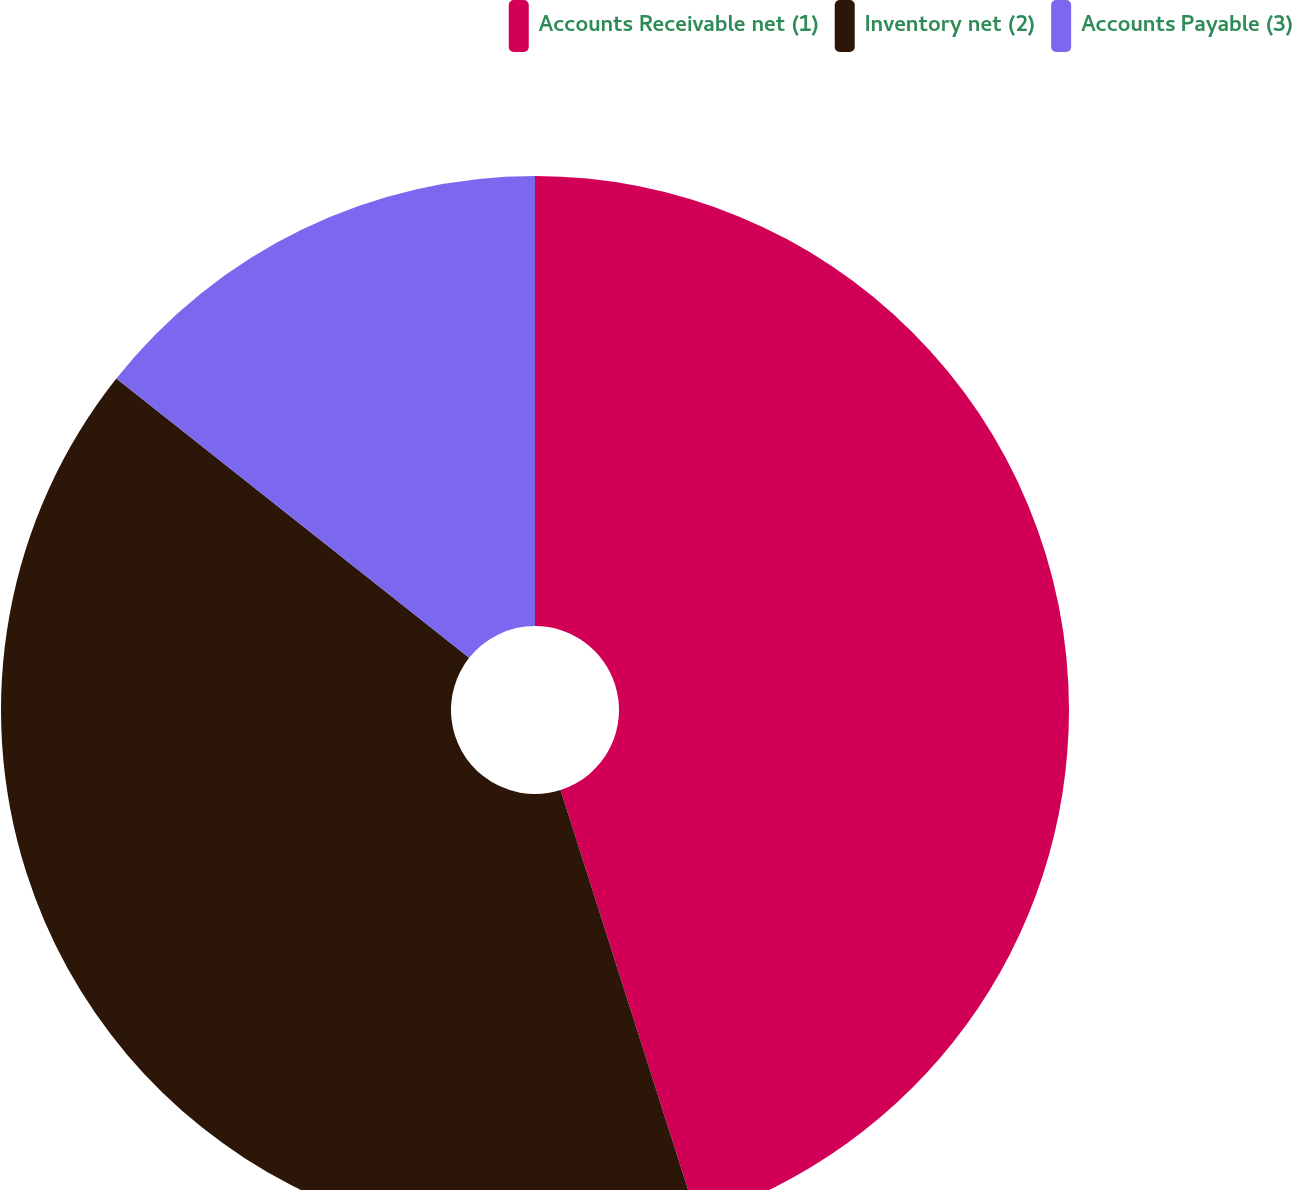<chart> <loc_0><loc_0><loc_500><loc_500><pie_chart><fcel>Accounts Receivable net (1)<fcel>Inventory net (2)<fcel>Accounts Payable (3)<nl><fcel>45.08%<fcel>40.57%<fcel>14.34%<nl></chart> 